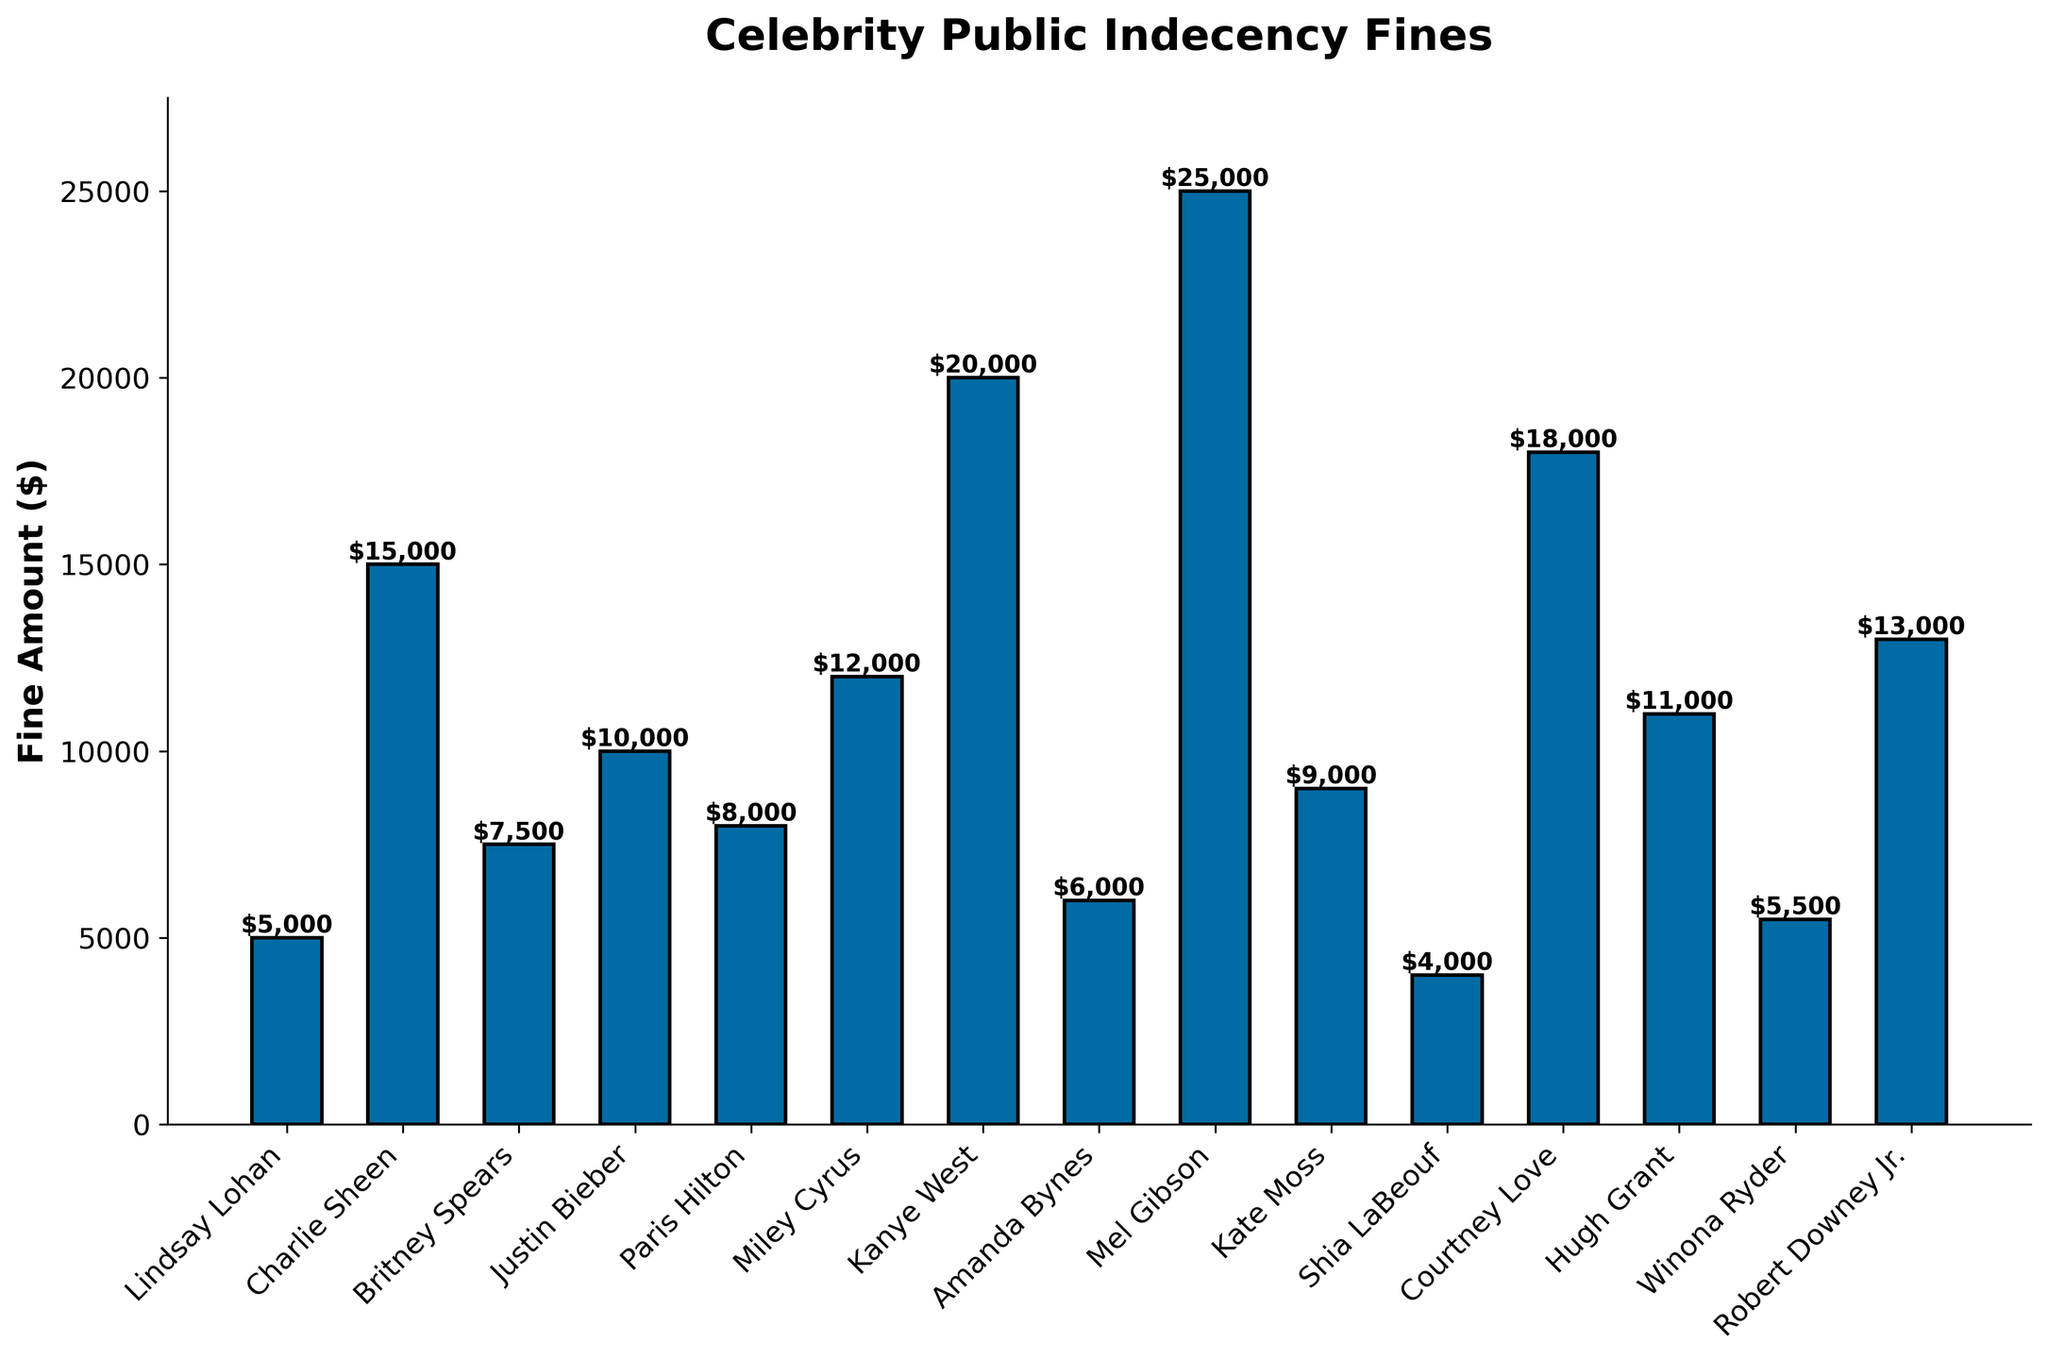Which celebrity received the highest fine? The figure shows a bar chart comparing fines for various celebrities. The tallest bar represents the highest fine.
Answer: Mel Gibson Who between Miley Cyrus and Britney Spears has a higher fine, and by how much? From the bar chart, find the height of bars for Miley Cyrus and Britney Spears and calculate the difference. Miley Cyrus received a $12,000 fine, and Britney Spears received a $7,500 fine. The difference is $12,000 - $7,500.
Answer: Miley Cyrus; $4,500 What’s the total fine amount for Lindsay Lohan, Amanda Bynes, and Shia LaBeouf? Add the fine amounts for each of these celebrities. Lindsay Lohan: $5,000, Amanda Bynes: $6,000, Shia LaBeouf: $4,000. Total fine amount is $5,000 + $6,000 + $4,000.
Answer: $15,000 Who is fined more: Justin Bieber or Kanye West, and by what percentage is one fine greater? Compare the fines for Justin Bieber ($10,000) and Kanye West ($20,000). Calculate the percentage difference using the formula: ((20,000 - 10,000) / 10,000) * 100.
Answer: Kanye West; 100% Which celebrity's fine is close to the average fine amount? First, calculate the average fine amount for all celebrities by summing up all fines and dividing by the number of celebrities. Then, identify the celebrity whose fine is closest to this average from the bar chart. Sum of all fines: $5000 + $15000 + $7500 + $10000 + $8000 + $12000 + $20000 + $6000 + $25000 + $9000 + $4000 + $18000 + $11000 + $5500 + $13000 = $159,000. There are 15 celebrities. Average fine = $159,000 / 15. The closest fine to the average is $10,600 (Hugh Grant with $11,000).
Answer: Hugh Grant How much more did Charlie Sheen pay in fines compared to Shia LaBeouf and Lindsay Lohan combined? Calculate the combined fine amount of Shia LaBeouf and Lindsay Lohan, then find the difference between this combined value and Charlie Sheen's fine. Shia LaBeouf: $4,000, Lindsay Lohan: $5,000. Combined: $4,000 + $5,000 = $9,000. Difference with Charlie Sheen's $15,000 fine: $15,000 - $9,000.
Answer: $6,000 What is the median fine amount among these celebrities? List all fine amounts in ascending order and then find the middle value. Ordered fines: $4000, $5000, $5500, $6000, $7500, $8000, $9000, $10000, $11000, $12000, $13000, $15000, $18000, $20000, $25000. The middle value (8th in this 15-item list) is $10,000.
Answer: $10,000 Which are the two celebrities closest in fine amounts, and what's the difference? Identify the pair of bars in the figure having the closest heights. Paris Hilton ($8,000) and Kate Moss ($9,000) have the smallest difference. Calculate the difference: $9,000 - $8,000.
Answer: Paris Hilton and Kate Moss; $1,000 How many celebrities were fined more than $10,000? Count the bars representing fines above the $10,000 mark in the bar chart.
Answer: 5 